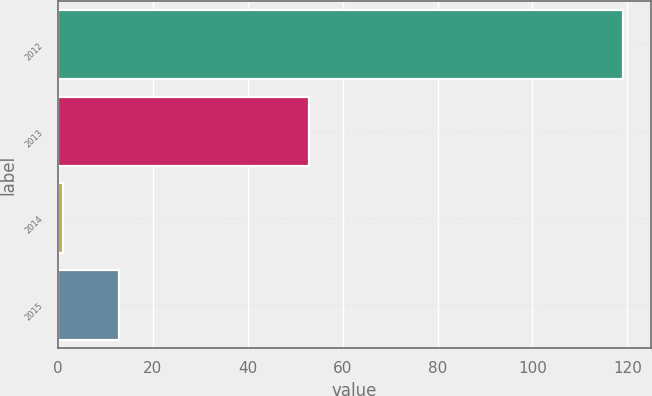Convert chart. <chart><loc_0><loc_0><loc_500><loc_500><bar_chart><fcel>2012<fcel>2013<fcel>2014<fcel>2015<nl><fcel>119<fcel>53<fcel>1<fcel>12.8<nl></chart> 